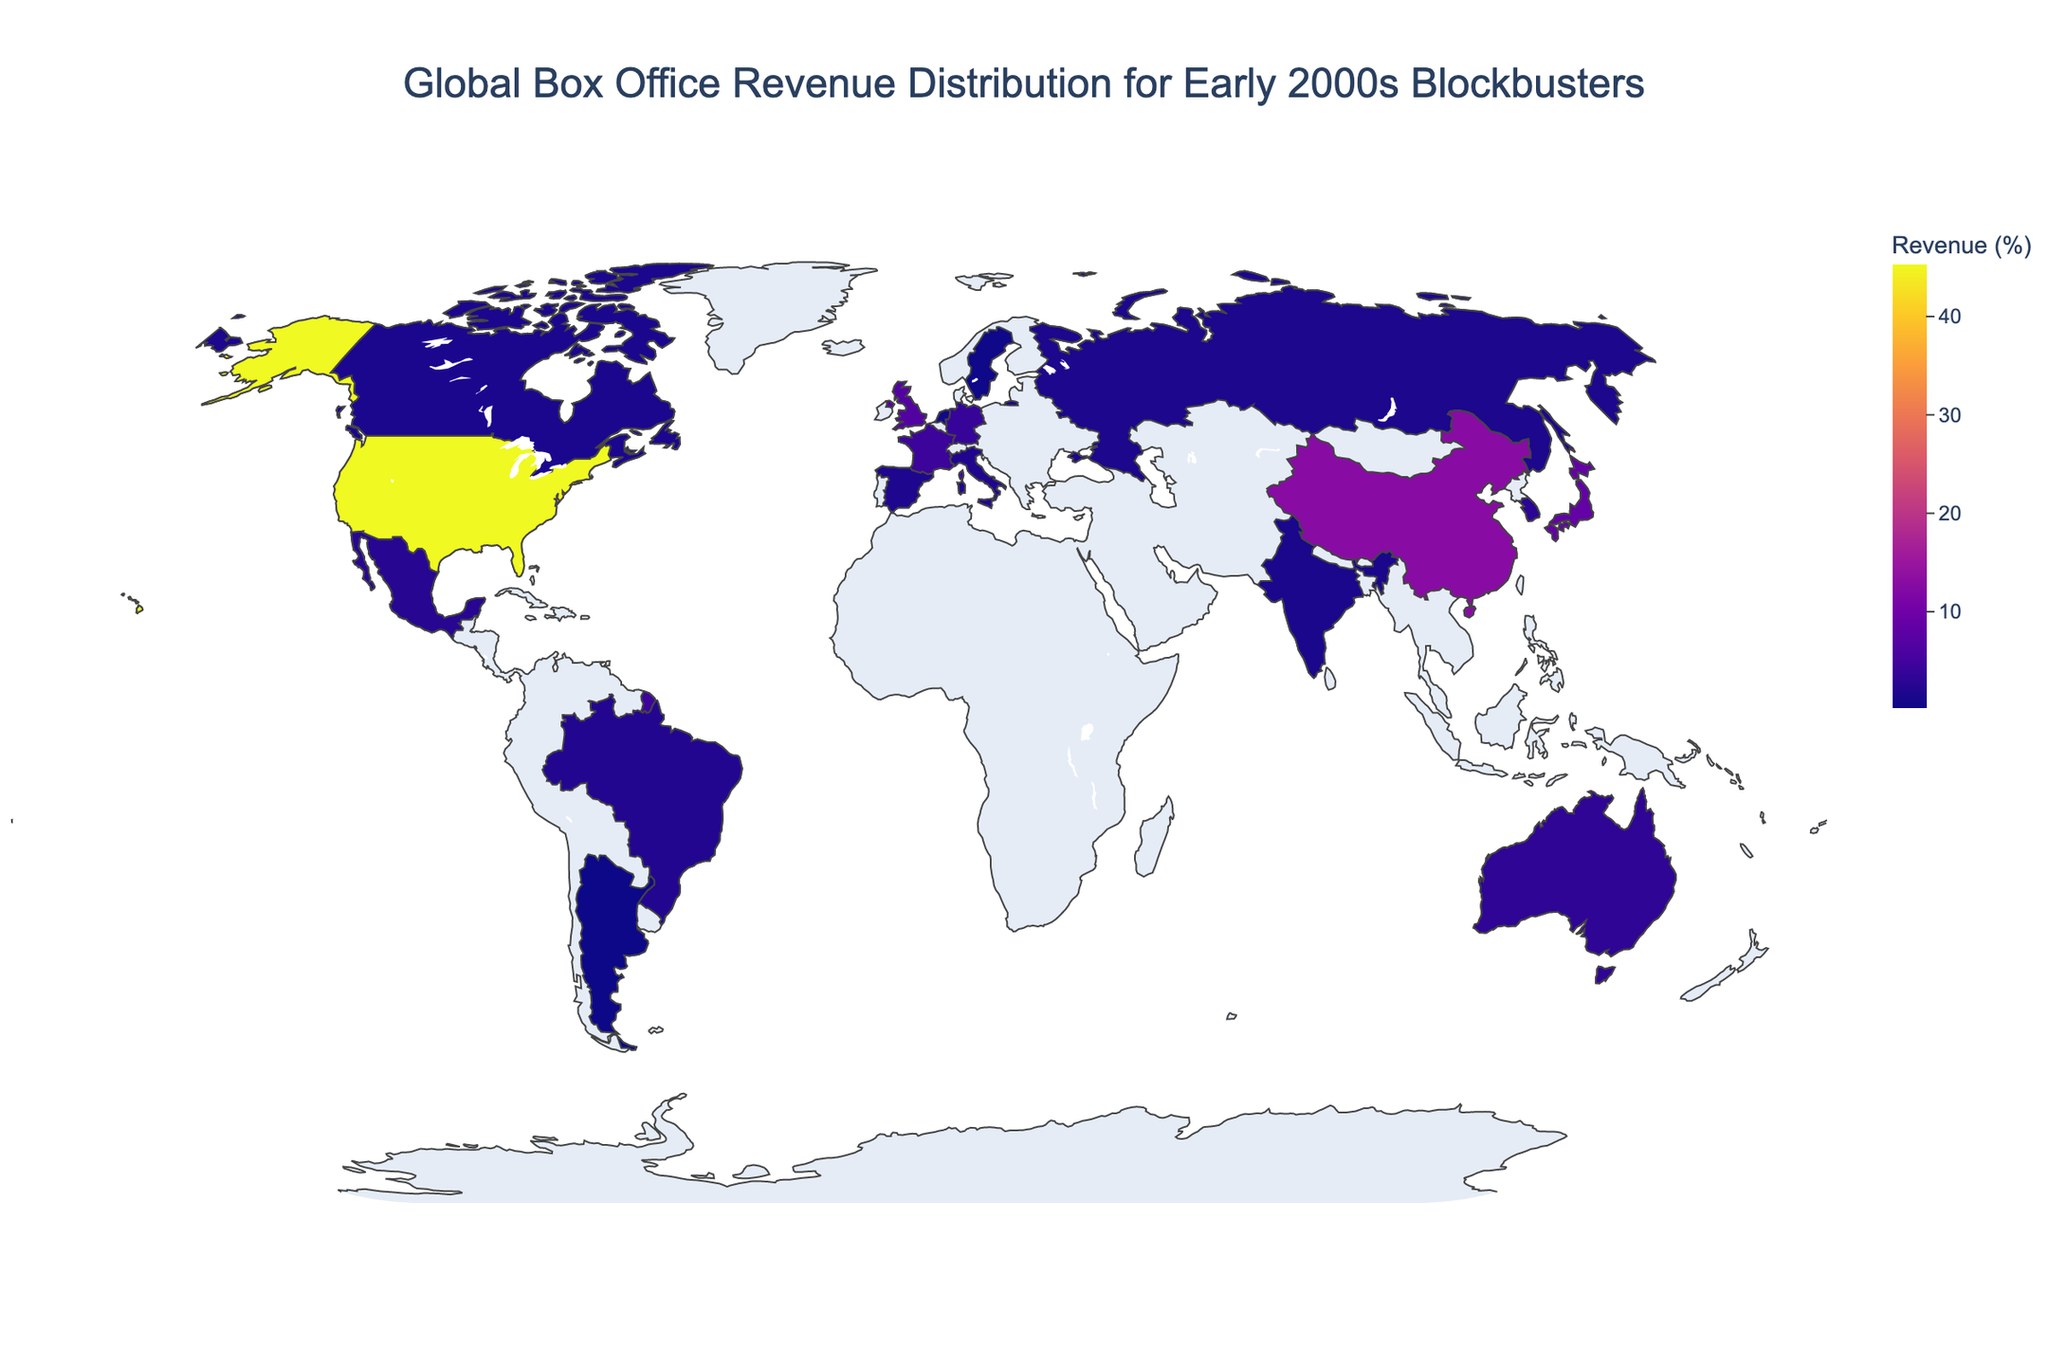What's the title of the plot? The title of the plot is typically found at the top of the figure. It provides a concise summary of what the figure represents.
Answer: Global Box Office Revenue Distribution for Early 2000s Blockbusters Which country has the highest box office revenue percentage? The country with the highest percentage will be the one with the largest numerical value in the color scale or legend.
Answer: United States What is the combined box office revenue percentage of China and Japan? To find the combined percentage, add the values for China and Japan. Based on the plot, China has 12.8% and Japan has 8.5%. 12.8 + 8.5 = 21.3%
Answer: 21.3% How does the box office revenue percentage of France compare to that of the United Kingdom? To compare, look at the values of both countries: France has 4.3%, and the United Kingdom has 6.7%. The United Kingdom has a higher percentage.
Answer: United Kingdom has a higher percentage Which country in South America has the highest box office revenue percentage? Identify the South American countries represented in the plot. The countries in South America listed are Brazil and Argentina, with Brazil having the higher percentage.
Answer: Brazil Which countries have a box office revenue percentage below 2%? List all the countries with percentages below 2% according to the figure. These are Italy (1.9%), Spain (1.7%), Russia (1.5%), Canada (1.4%), India (1.3%), Netherlands (0.6%), Sweden (0.4%), and Argentina (0.2%).
Answer: Italy, Spain, Russia, Canada, India, Netherlands, Sweden, Argentina What's the difference in box office revenue percentage between Germany and Australia? To find the difference, subtract the smaller percentage from the larger one: Germany has 3.9% and Australia has 3.2%, so 3.9 - 3.2 = 0.7%.
Answer: 0.7% What is the average box office revenue percentage of the top three countries? First, identify the top three countries: United States (45.2%), China (12.8%), and Japan (8.5%). Then calculate the average: (45.2 + 12.8 + 8.5) / 3 = 22.17%
Answer: 22.17% Which country in North America has a box office revenue percentage closest to 2%? The countries in North America listed are the United States, Mexico, and Canada. Mexico has 2.5%, closest to 2%.
Answer: Mexico 